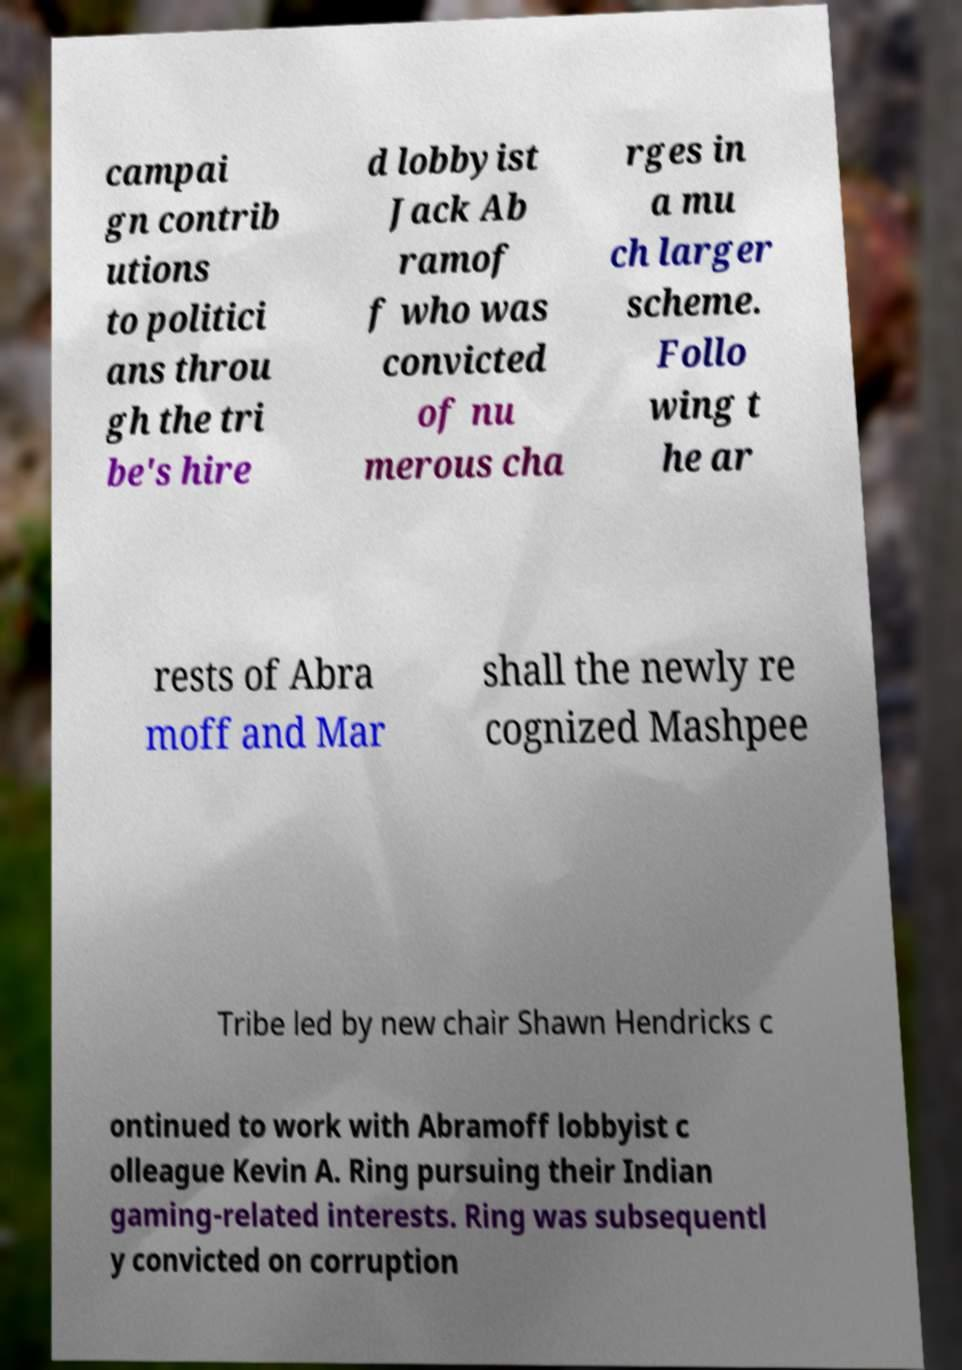Please identify and transcribe the text found in this image. campai gn contrib utions to politici ans throu gh the tri be's hire d lobbyist Jack Ab ramof f who was convicted of nu merous cha rges in a mu ch larger scheme. Follo wing t he ar rests of Abra moff and Mar shall the newly re cognized Mashpee Tribe led by new chair Shawn Hendricks c ontinued to work with Abramoff lobbyist c olleague Kevin A. Ring pursuing their Indian gaming-related interests. Ring was subsequentl y convicted on corruption 